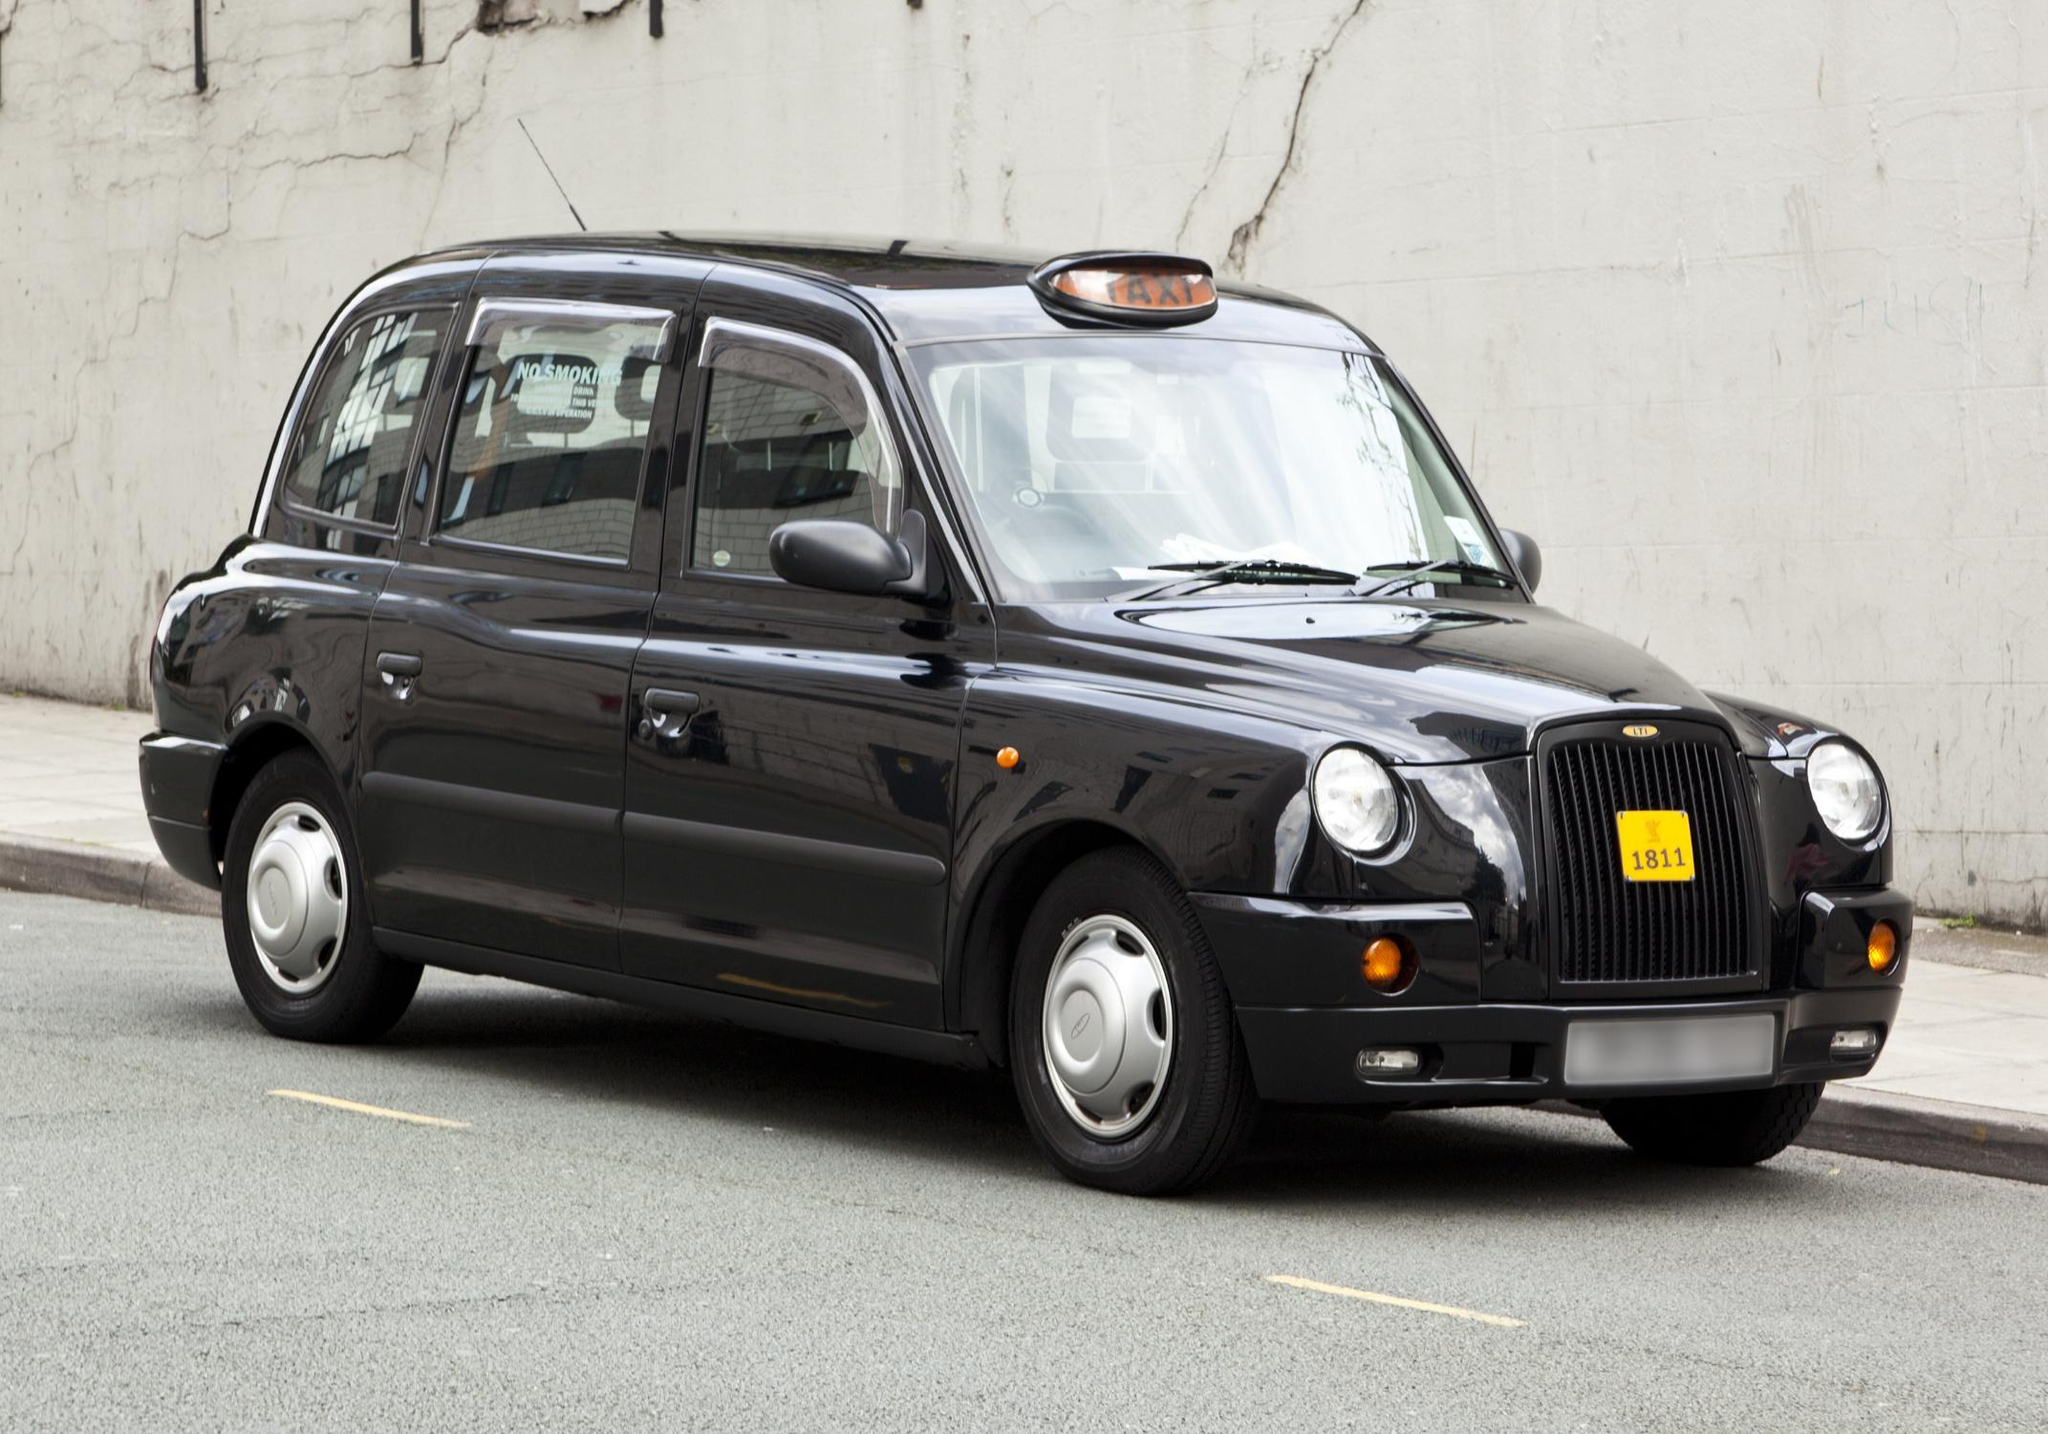Explain the visual content of the image in great detail. The image shows a classic black London taxi, distinguished by its iconic design, parked against a weathered white wall on a city street. The taxi's registration plate, prominently visible, adds authenticity to its London heritage. The car features the typical rounded body shape and high roof of London cabs, designed for passenger comfort. It sports a gleaming black finish, matched with chrome details around the headlights and grill, providing a touch of elegance to its utilitarian design. The taxi sign on the roof is illuminated in orange, indicating it is ready for hire. The backdrop is an unadorned urban environment with subtle signs of wear, hinting at the everyday hustle of city life. 